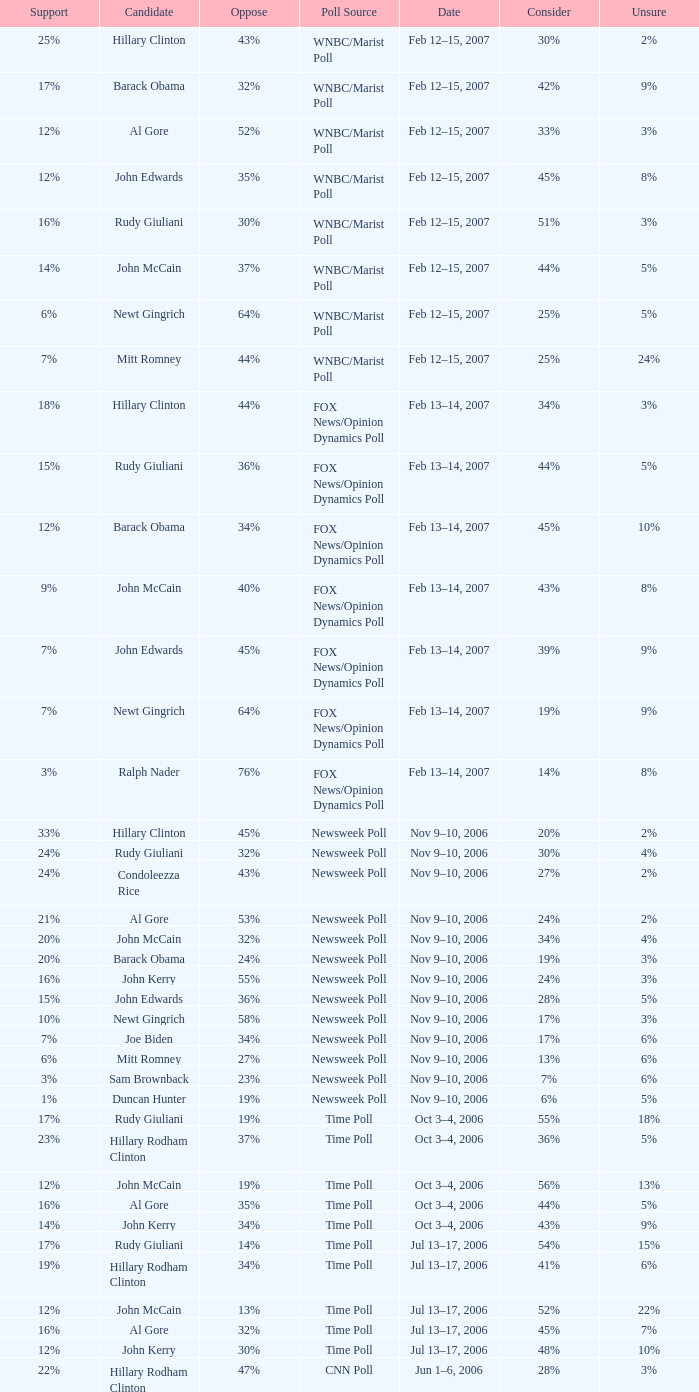What percentage of people were opposed to the candidate based on the Time Poll poll that showed 6% of people were unsure? 34%. 